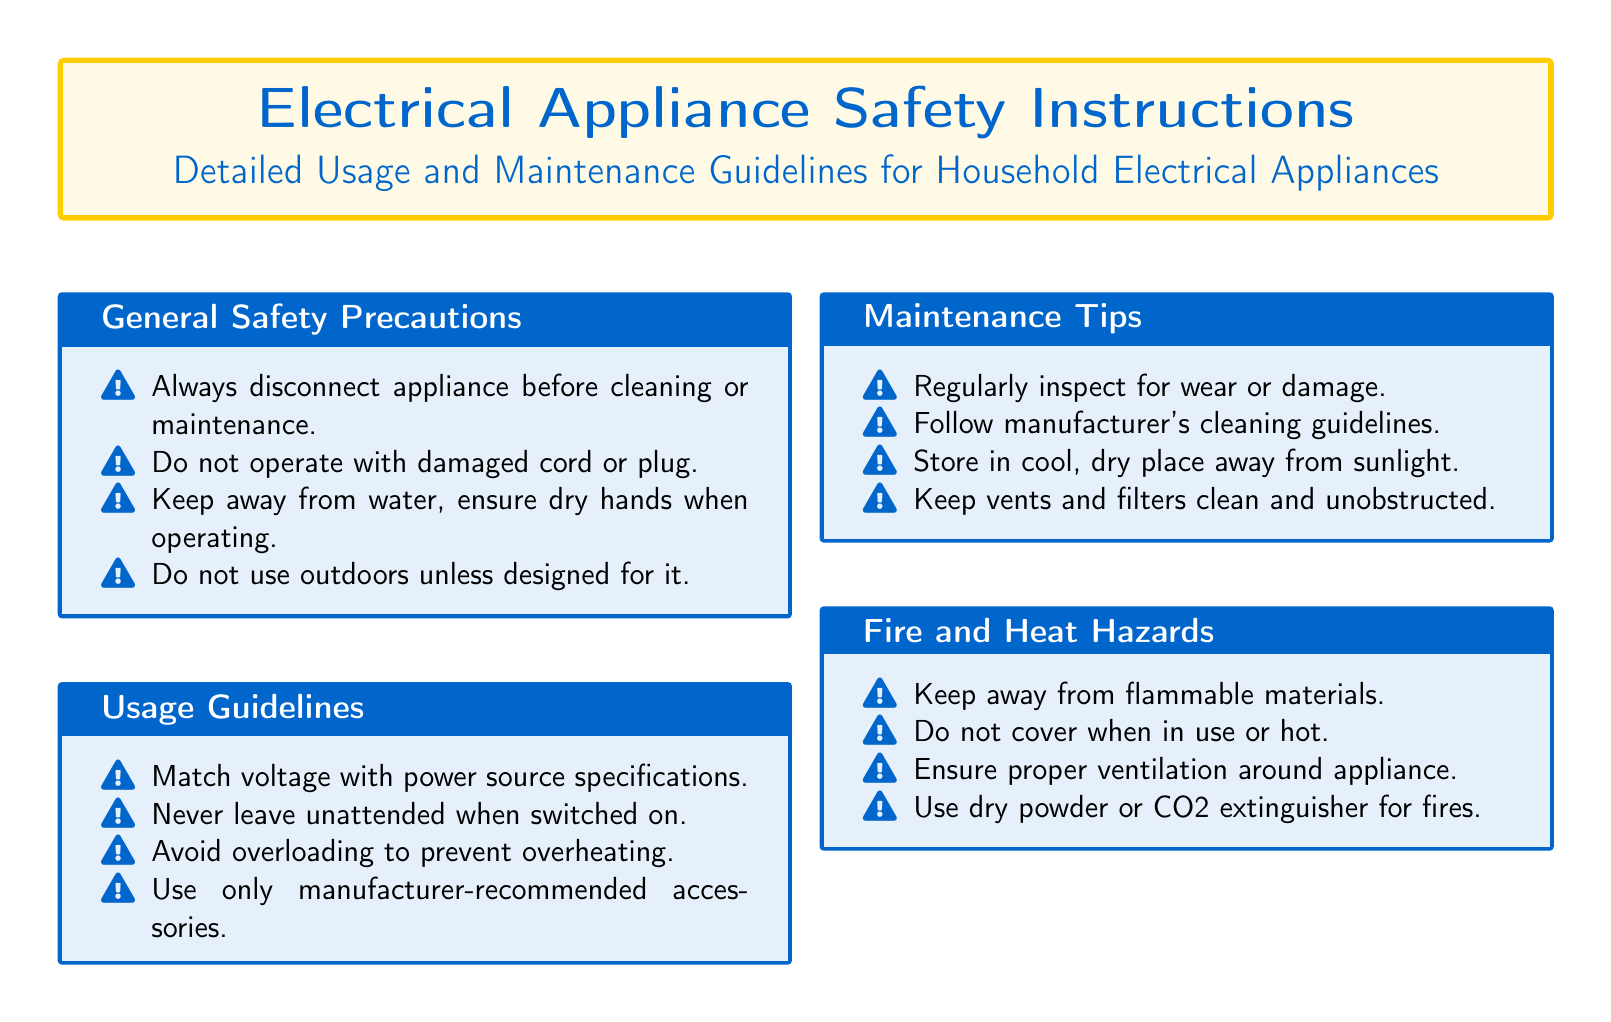What is the main title of the document? The main title is presented prominently at the top of the document in a larger font.
Answer: Electrical Appliance Safety Instructions How many sections are in the document? The document contains four main sections, each with specific guidelines and precautions.
Answer: 4 What should you do before cleaning the appliance? The guideline emphasizes an important safety measure before maintenance tasks.
Answer: Disconnect appliance What kind of extinguisher should be used for fires? The document specifies the appropriate type of extinguisher that is effective for electrical appliance fires.
Answer: Dry powder or CO2 What is one guideline for using the appliance? This guideline advises on the operational aspect of safety during usage.
Answer: Never leave unattended when switched on Why should you keep vents and filters clean? The document explains an aspect of maintenance to ensure safe operation of appliances.
Answer: To prevent overheating 